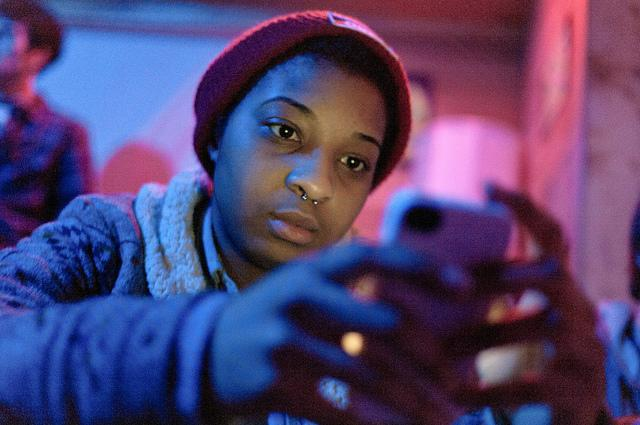What kind of media is she consuming?

Choices:
A) television
B) film
C) digital
D) print digital 